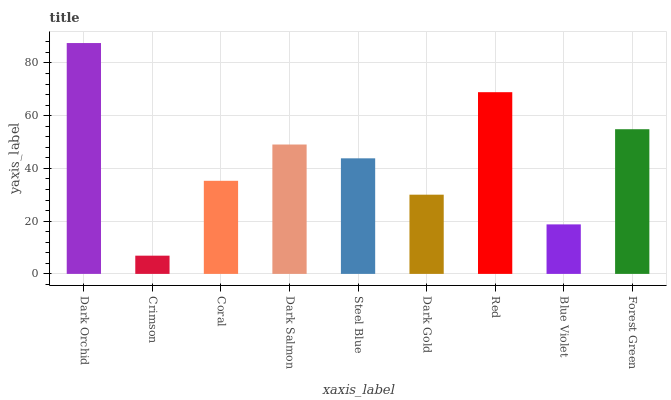Is Crimson the minimum?
Answer yes or no. Yes. Is Dark Orchid the maximum?
Answer yes or no. Yes. Is Coral the minimum?
Answer yes or no. No. Is Coral the maximum?
Answer yes or no. No. Is Coral greater than Crimson?
Answer yes or no. Yes. Is Crimson less than Coral?
Answer yes or no. Yes. Is Crimson greater than Coral?
Answer yes or no. No. Is Coral less than Crimson?
Answer yes or no. No. Is Steel Blue the high median?
Answer yes or no. Yes. Is Steel Blue the low median?
Answer yes or no. Yes. Is Red the high median?
Answer yes or no. No. Is Coral the low median?
Answer yes or no. No. 